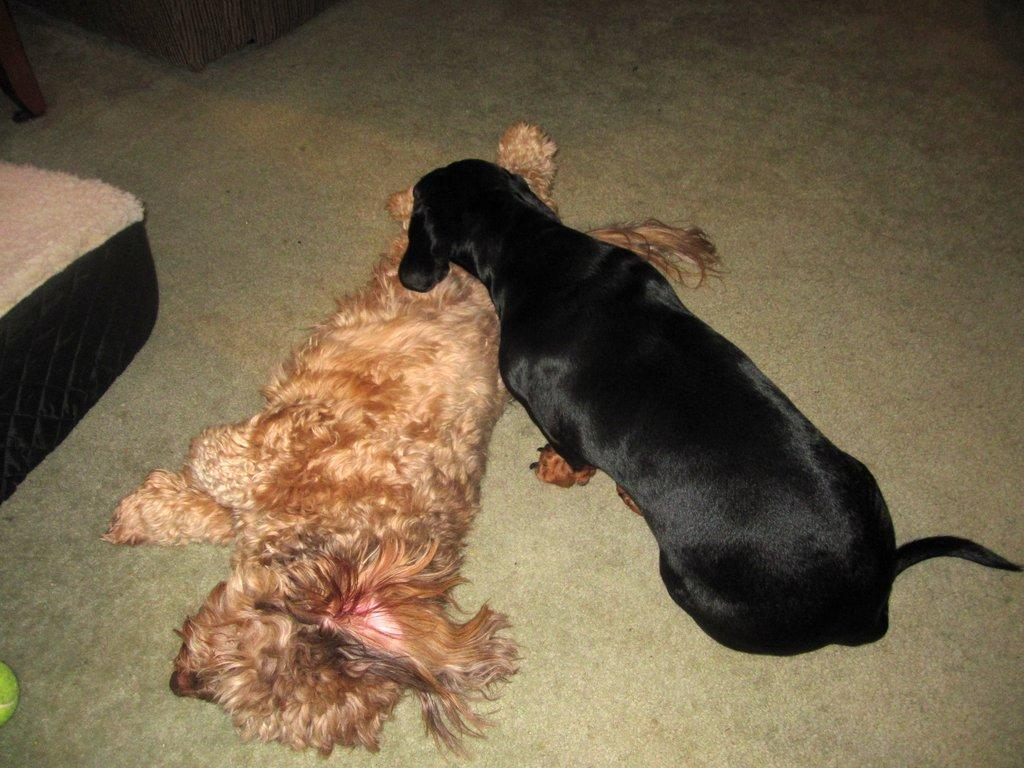How many dogs are present in the image? There are two dogs in the image. What surface are the dogs on? The dogs are on a surface, but the specific type of surface is not mentioned in the facts. What else can be seen in the image besides the dogs? There are objects placed in the image, but their specific nature is not mentioned in the facts. What type of club is located in the middle of the image? There is no club present in the image. 